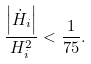<formula> <loc_0><loc_0><loc_500><loc_500>\frac { \left | \dot { H } _ { i } \right | } { H _ { i } ^ { 2 } } < \frac { 1 } { 7 5 } .</formula> 